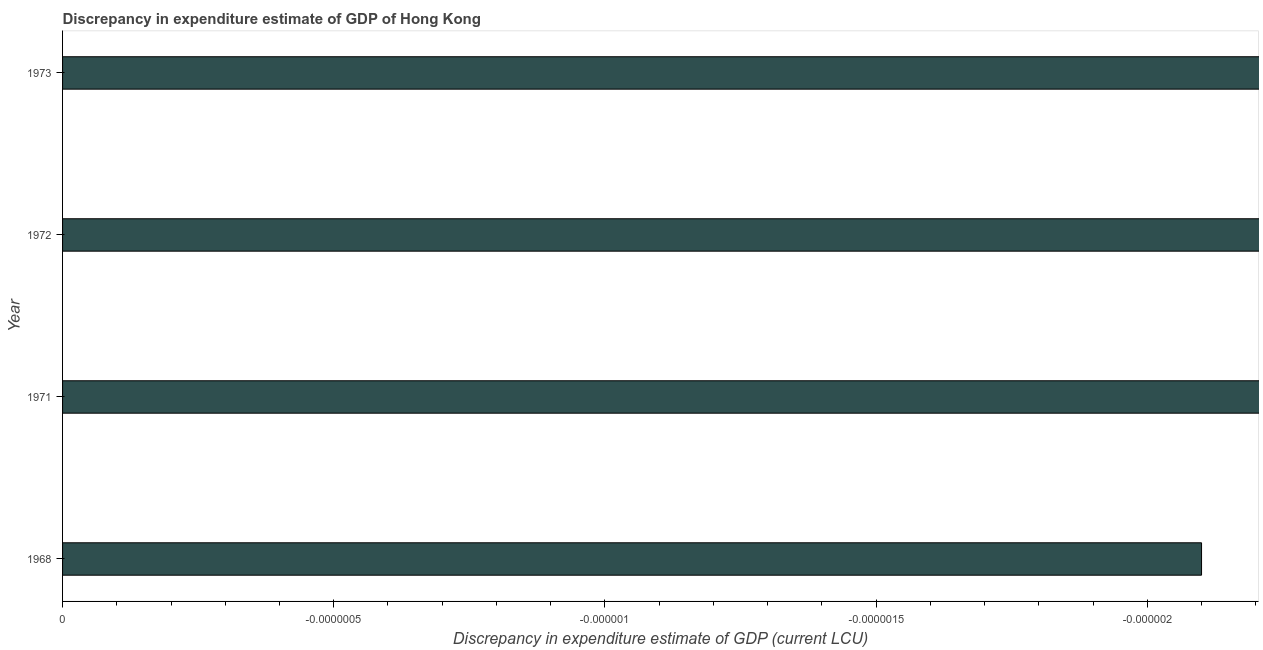Does the graph contain any zero values?
Keep it short and to the point. Yes. What is the title of the graph?
Ensure brevity in your answer.  Discrepancy in expenditure estimate of GDP of Hong Kong. What is the label or title of the X-axis?
Your answer should be compact. Discrepancy in expenditure estimate of GDP (current LCU). What is the label or title of the Y-axis?
Your answer should be compact. Year. How many years are there in the graph?
Offer a terse response. 4. What is the difference between two consecutive major ticks on the X-axis?
Offer a terse response. 4.999999999999999e-7. Are the values on the major ticks of X-axis written in scientific E-notation?
Keep it short and to the point. No. What is the Discrepancy in expenditure estimate of GDP (current LCU) of 1972?
Your answer should be very brief. 0. 